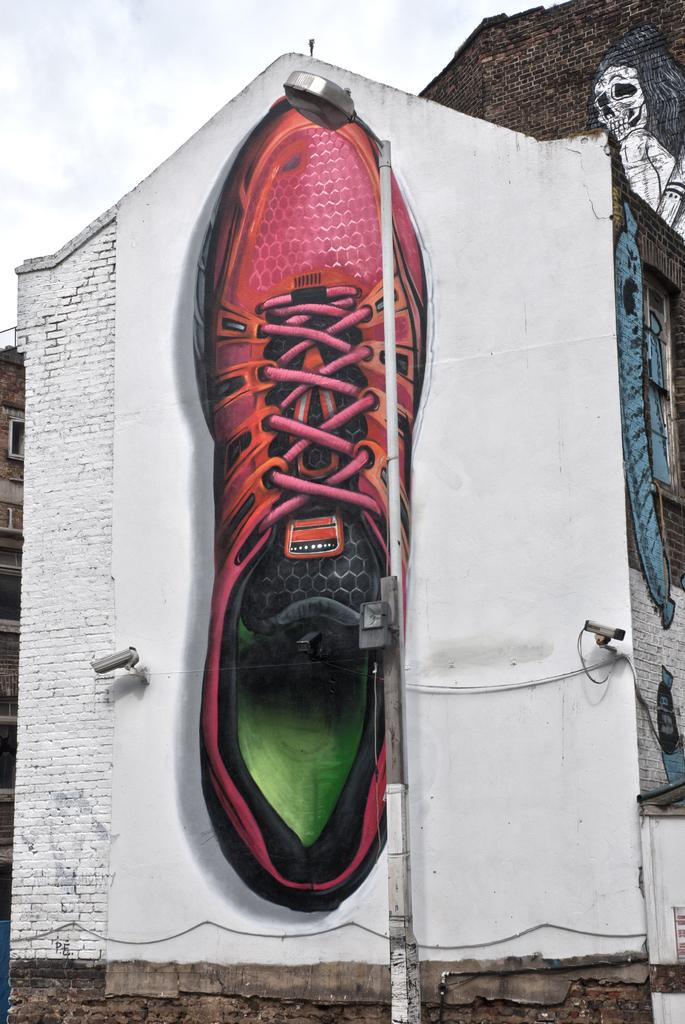What is depicted on the buildings in the image? There are paintings on the buildings in the image. What type of object can be seen providing light in the image? There is a street light in the image. Where is the building located in the image? There is a building on the left side of the image. How many frogs are sitting on the hill in the image? There is no hill or frogs present in the image. Can you describe the monkey's expression in the image? There is no monkey present in the image. 